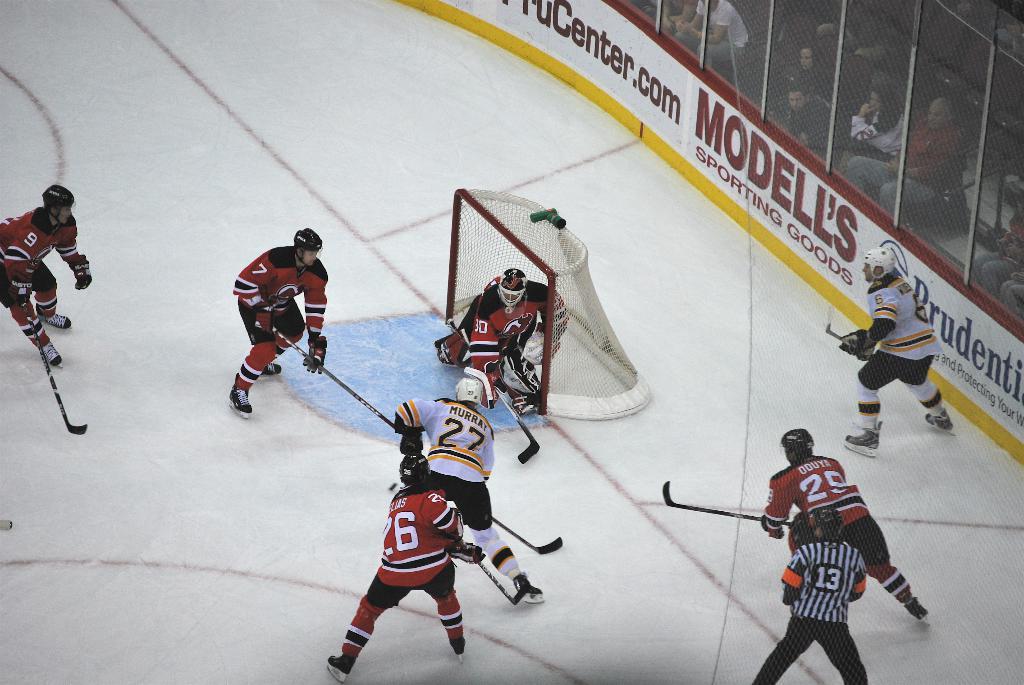What is one of the company's advertising on the rink?
Provide a short and direct response. Modell's. What number is the referee?
Give a very brief answer. 13. 